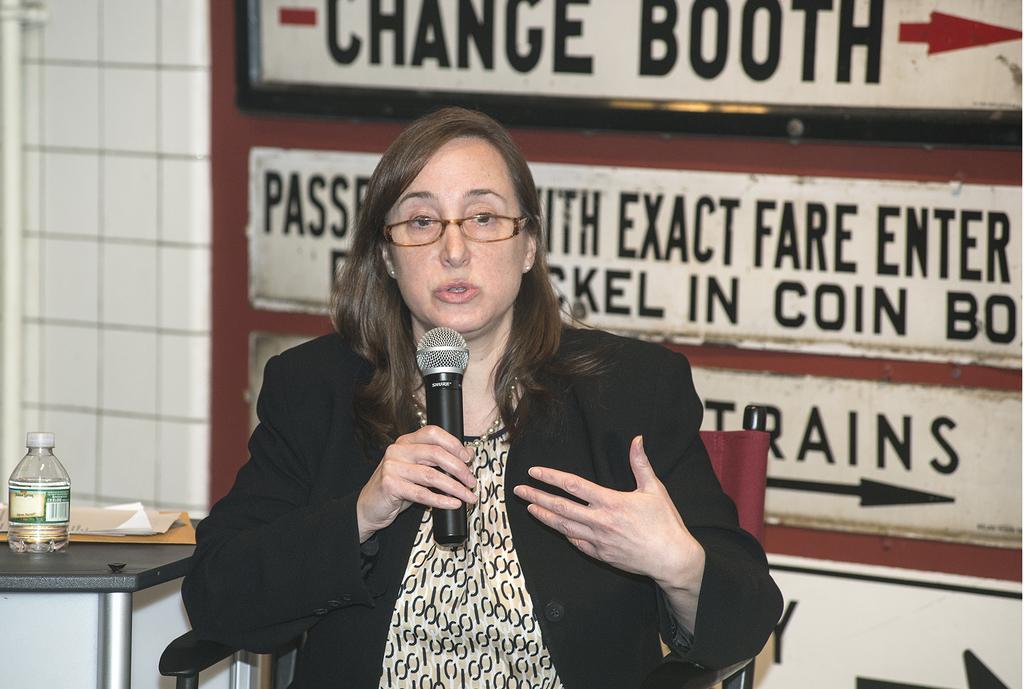In one or two sentences, can you explain what this image depicts? In the middle of the image a woman is sitting and holding a microphone and speaking. Bottom left side of the image there is a table, On the table there are some papers and bottle. Behind her there is a wall. 